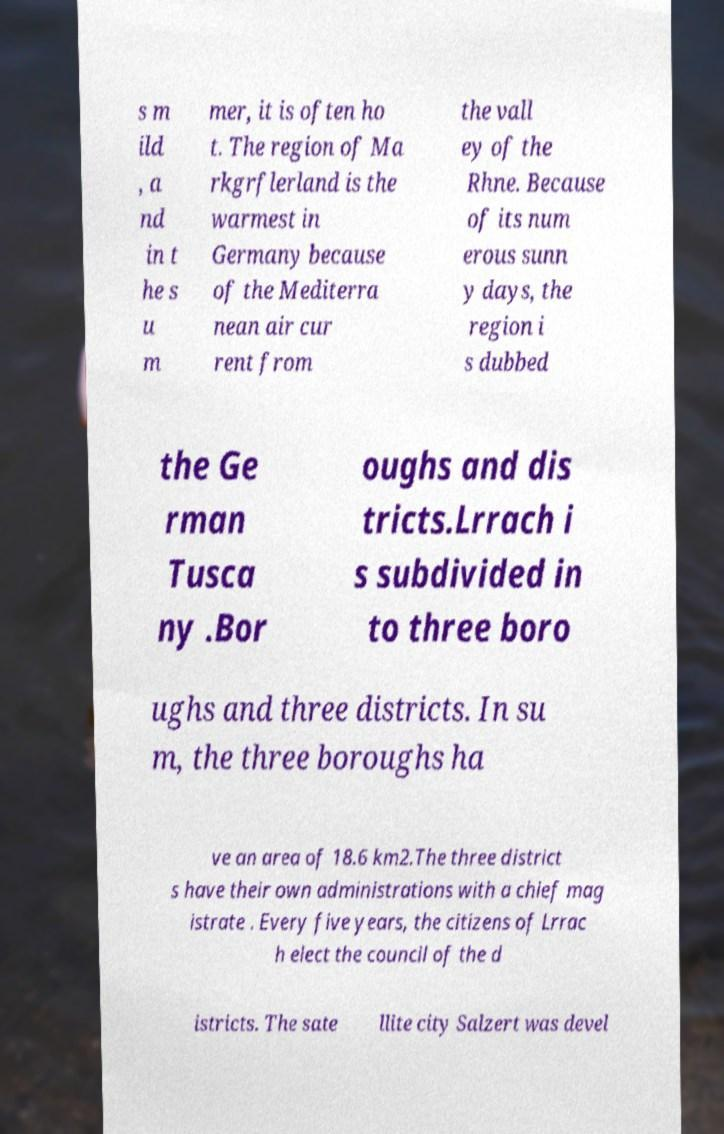For documentation purposes, I need the text within this image transcribed. Could you provide that? s m ild , a nd in t he s u m mer, it is often ho t. The region of Ma rkgrflerland is the warmest in Germany because of the Mediterra nean air cur rent from the vall ey of the Rhne. Because of its num erous sunn y days, the region i s dubbed the Ge rman Tusca ny .Bor oughs and dis tricts.Lrrach i s subdivided in to three boro ughs and three districts. In su m, the three boroughs ha ve an area of 18.6 km2.The three district s have their own administrations with a chief mag istrate . Every five years, the citizens of Lrrac h elect the council of the d istricts. The sate llite city Salzert was devel 